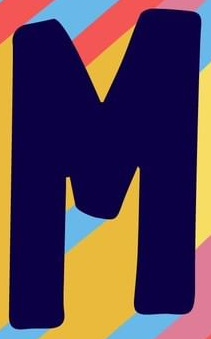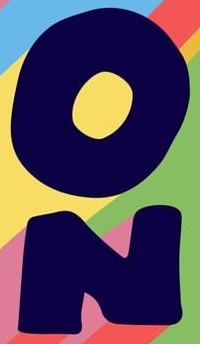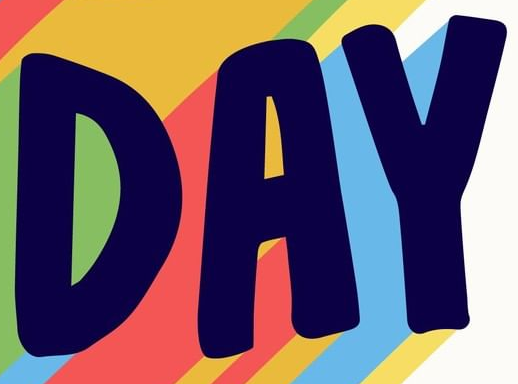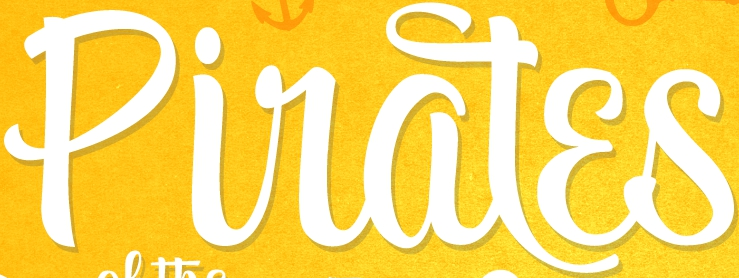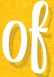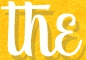Identify the words shown in these images in order, separated by a semicolon. M; ON; DAY; Piratɛs; of; the 